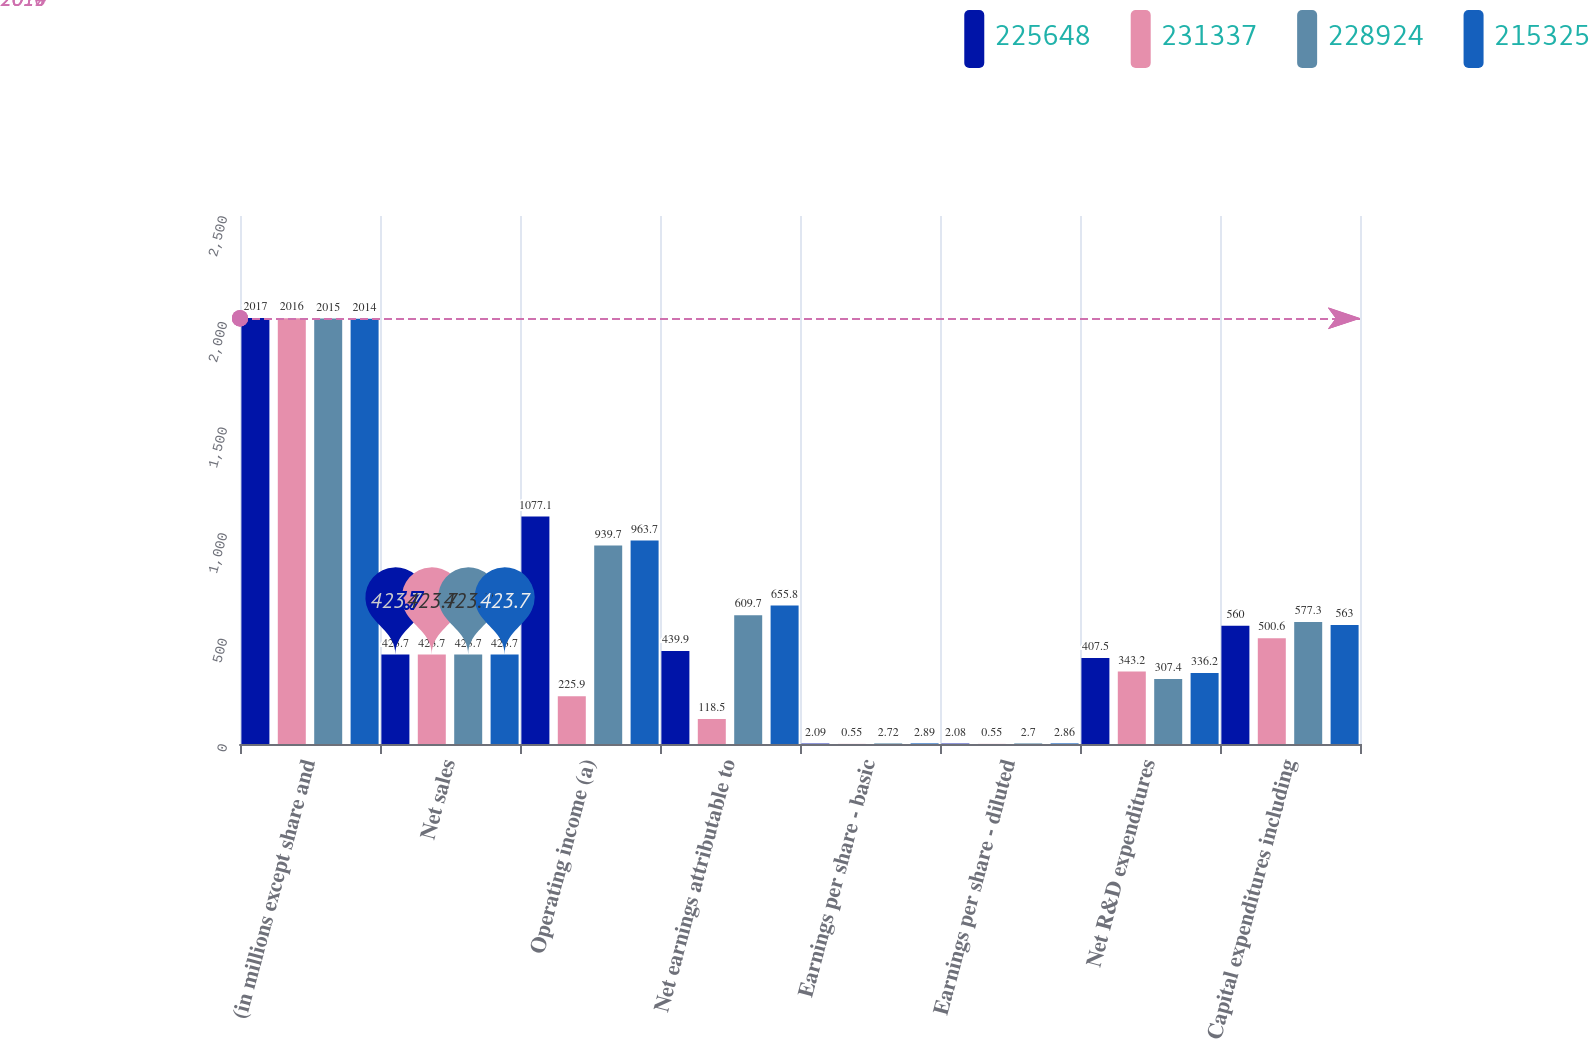Convert chart to OTSL. <chart><loc_0><loc_0><loc_500><loc_500><stacked_bar_chart><ecel><fcel>(in millions except share and<fcel>Net sales<fcel>Operating income (a)<fcel>Net earnings attributable to<fcel>Earnings per share - basic<fcel>Earnings per share - diluted<fcel>Net R&D expenditures<fcel>Capital expenditures including<nl><fcel>225648<fcel>2017<fcel>423.7<fcel>1077.1<fcel>439.9<fcel>2.09<fcel>2.08<fcel>407.5<fcel>560<nl><fcel>231337<fcel>2016<fcel>423.7<fcel>225.9<fcel>118.5<fcel>0.55<fcel>0.55<fcel>343.2<fcel>500.6<nl><fcel>228924<fcel>2015<fcel>423.7<fcel>939.7<fcel>609.7<fcel>2.72<fcel>2.7<fcel>307.4<fcel>577.3<nl><fcel>215325<fcel>2014<fcel>423.7<fcel>963.7<fcel>655.8<fcel>2.89<fcel>2.86<fcel>336.2<fcel>563<nl></chart> 